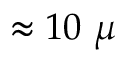<formula> <loc_0><loc_0><loc_500><loc_500>\approx 1 0 \mu</formula> 